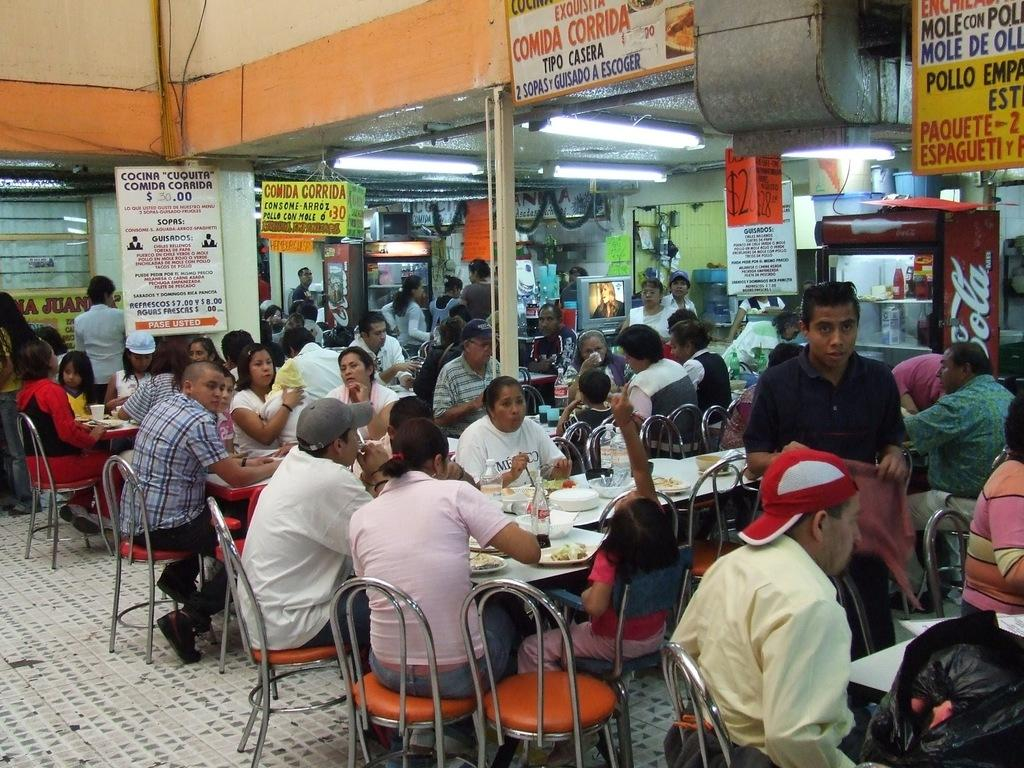What are the people in the image doing? The people in the image are sitting on chairs. What can be seen on the wall in the image? There is a poster and a banner on the wall in the image. What is visible through the window in the image? The image does not show what is visible through the window. What items are present on the tables in the image? There are plates, bottles, and glasses on the tables in the image. What type of sweater is the person wearing in the image? There are no people wearing sweaters in the image; they are sitting on chairs with no visible clothing mentioned. 